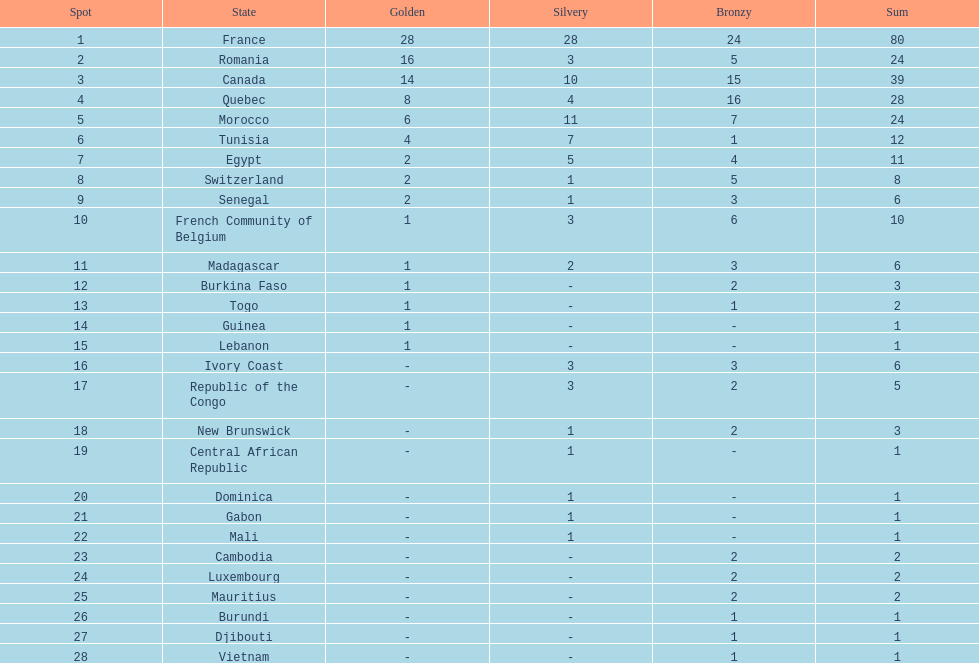How many more medals did egypt win than ivory coast? 5. 